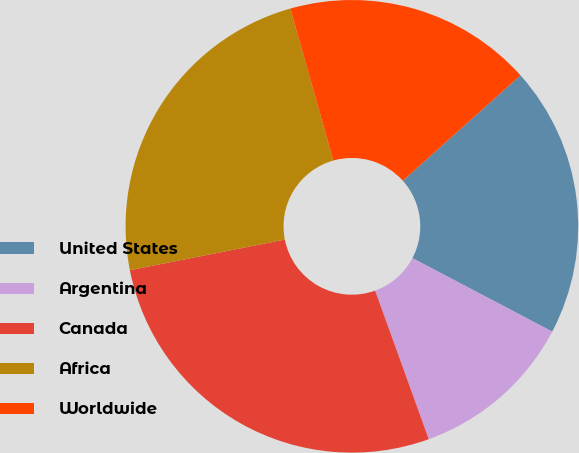Convert chart. <chart><loc_0><loc_0><loc_500><loc_500><pie_chart><fcel>United States<fcel>Argentina<fcel>Canada<fcel>Africa<fcel>Worldwide<nl><fcel>19.33%<fcel>11.78%<fcel>27.41%<fcel>23.72%<fcel>17.76%<nl></chart> 